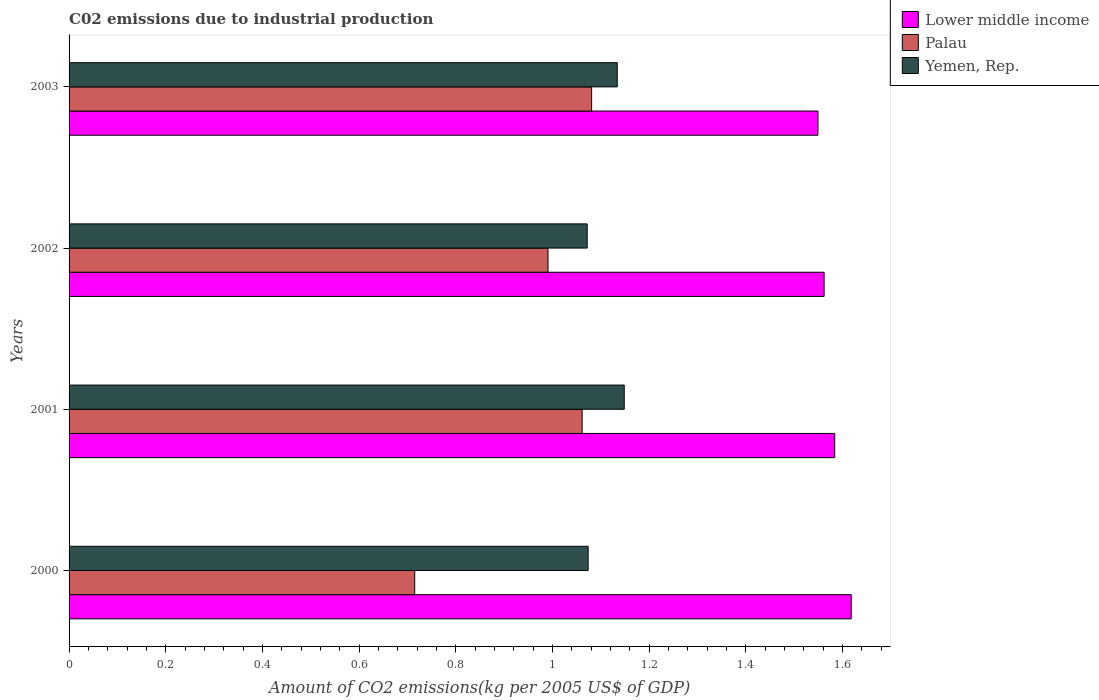How many different coloured bars are there?
Your answer should be very brief. 3. How many bars are there on the 3rd tick from the bottom?
Your response must be concise. 3. What is the amount of CO2 emitted due to industrial production in Lower middle income in 2002?
Your answer should be compact. 1.56. Across all years, what is the maximum amount of CO2 emitted due to industrial production in Yemen, Rep.?
Your answer should be compact. 1.15. Across all years, what is the minimum amount of CO2 emitted due to industrial production in Lower middle income?
Your response must be concise. 1.55. In which year was the amount of CO2 emitted due to industrial production in Palau maximum?
Offer a terse response. 2003. What is the total amount of CO2 emitted due to industrial production in Yemen, Rep. in the graph?
Provide a succinct answer. 4.43. What is the difference between the amount of CO2 emitted due to industrial production in Lower middle income in 2001 and that in 2003?
Provide a short and direct response. 0.03. What is the difference between the amount of CO2 emitted due to industrial production in Lower middle income in 2000 and the amount of CO2 emitted due to industrial production in Palau in 2001?
Your answer should be very brief. 0.56. What is the average amount of CO2 emitted due to industrial production in Lower middle income per year?
Offer a terse response. 1.58. In the year 2003, what is the difference between the amount of CO2 emitted due to industrial production in Palau and amount of CO2 emitted due to industrial production in Yemen, Rep.?
Your response must be concise. -0.05. In how many years, is the amount of CO2 emitted due to industrial production in Palau greater than 0.32 kg?
Give a very brief answer. 4. What is the ratio of the amount of CO2 emitted due to industrial production in Palau in 2000 to that in 2003?
Your answer should be very brief. 0.66. Is the amount of CO2 emitted due to industrial production in Yemen, Rep. in 2001 less than that in 2003?
Give a very brief answer. No. What is the difference between the highest and the second highest amount of CO2 emitted due to industrial production in Yemen, Rep.?
Your answer should be compact. 0.01. What is the difference between the highest and the lowest amount of CO2 emitted due to industrial production in Yemen, Rep.?
Provide a short and direct response. 0.08. Is the sum of the amount of CO2 emitted due to industrial production in Yemen, Rep. in 2001 and 2002 greater than the maximum amount of CO2 emitted due to industrial production in Lower middle income across all years?
Your answer should be very brief. Yes. What does the 1st bar from the top in 2002 represents?
Offer a very short reply. Yemen, Rep. What does the 3rd bar from the bottom in 2003 represents?
Provide a short and direct response. Yemen, Rep. How many legend labels are there?
Offer a very short reply. 3. How are the legend labels stacked?
Your answer should be very brief. Vertical. What is the title of the graph?
Your answer should be very brief. C02 emissions due to industrial production. What is the label or title of the X-axis?
Give a very brief answer. Amount of CO2 emissions(kg per 2005 US$ of GDP). What is the Amount of CO2 emissions(kg per 2005 US$ of GDP) of Lower middle income in 2000?
Give a very brief answer. 1.62. What is the Amount of CO2 emissions(kg per 2005 US$ of GDP) in Palau in 2000?
Make the answer very short. 0.71. What is the Amount of CO2 emissions(kg per 2005 US$ of GDP) in Yemen, Rep. in 2000?
Offer a very short reply. 1.07. What is the Amount of CO2 emissions(kg per 2005 US$ of GDP) of Lower middle income in 2001?
Give a very brief answer. 1.58. What is the Amount of CO2 emissions(kg per 2005 US$ of GDP) of Palau in 2001?
Your response must be concise. 1.06. What is the Amount of CO2 emissions(kg per 2005 US$ of GDP) in Yemen, Rep. in 2001?
Your response must be concise. 1.15. What is the Amount of CO2 emissions(kg per 2005 US$ of GDP) of Lower middle income in 2002?
Make the answer very short. 1.56. What is the Amount of CO2 emissions(kg per 2005 US$ of GDP) in Palau in 2002?
Your answer should be compact. 0.99. What is the Amount of CO2 emissions(kg per 2005 US$ of GDP) of Yemen, Rep. in 2002?
Offer a very short reply. 1.07. What is the Amount of CO2 emissions(kg per 2005 US$ of GDP) of Lower middle income in 2003?
Give a very brief answer. 1.55. What is the Amount of CO2 emissions(kg per 2005 US$ of GDP) of Palau in 2003?
Ensure brevity in your answer.  1.08. What is the Amount of CO2 emissions(kg per 2005 US$ of GDP) in Yemen, Rep. in 2003?
Make the answer very short. 1.13. Across all years, what is the maximum Amount of CO2 emissions(kg per 2005 US$ of GDP) of Lower middle income?
Provide a succinct answer. 1.62. Across all years, what is the maximum Amount of CO2 emissions(kg per 2005 US$ of GDP) of Palau?
Your answer should be compact. 1.08. Across all years, what is the maximum Amount of CO2 emissions(kg per 2005 US$ of GDP) in Yemen, Rep.?
Your response must be concise. 1.15. Across all years, what is the minimum Amount of CO2 emissions(kg per 2005 US$ of GDP) of Lower middle income?
Keep it short and to the point. 1.55. Across all years, what is the minimum Amount of CO2 emissions(kg per 2005 US$ of GDP) in Palau?
Offer a terse response. 0.71. Across all years, what is the minimum Amount of CO2 emissions(kg per 2005 US$ of GDP) of Yemen, Rep.?
Your answer should be very brief. 1.07. What is the total Amount of CO2 emissions(kg per 2005 US$ of GDP) of Lower middle income in the graph?
Keep it short and to the point. 6.31. What is the total Amount of CO2 emissions(kg per 2005 US$ of GDP) in Palau in the graph?
Offer a terse response. 3.85. What is the total Amount of CO2 emissions(kg per 2005 US$ of GDP) of Yemen, Rep. in the graph?
Ensure brevity in your answer.  4.43. What is the difference between the Amount of CO2 emissions(kg per 2005 US$ of GDP) in Lower middle income in 2000 and that in 2001?
Offer a terse response. 0.03. What is the difference between the Amount of CO2 emissions(kg per 2005 US$ of GDP) of Palau in 2000 and that in 2001?
Provide a short and direct response. -0.35. What is the difference between the Amount of CO2 emissions(kg per 2005 US$ of GDP) in Yemen, Rep. in 2000 and that in 2001?
Make the answer very short. -0.07. What is the difference between the Amount of CO2 emissions(kg per 2005 US$ of GDP) of Lower middle income in 2000 and that in 2002?
Give a very brief answer. 0.06. What is the difference between the Amount of CO2 emissions(kg per 2005 US$ of GDP) of Palau in 2000 and that in 2002?
Provide a succinct answer. -0.28. What is the difference between the Amount of CO2 emissions(kg per 2005 US$ of GDP) in Yemen, Rep. in 2000 and that in 2002?
Make the answer very short. 0. What is the difference between the Amount of CO2 emissions(kg per 2005 US$ of GDP) in Lower middle income in 2000 and that in 2003?
Your response must be concise. 0.07. What is the difference between the Amount of CO2 emissions(kg per 2005 US$ of GDP) in Palau in 2000 and that in 2003?
Your answer should be compact. -0.37. What is the difference between the Amount of CO2 emissions(kg per 2005 US$ of GDP) in Yemen, Rep. in 2000 and that in 2003?
Your answer should be very brief. -0.06. What is the difference between the Amount of CO2 emissions(kg per 2005 US$ of GDP) in Lower middle income in 2001 and that in 2002?
Provide a short and direct response. 0.02. What is the difference between the Amount of CO2 emissions(kg per 2005 US$ of GDP) in Palau in 2001 and that in 2002?
Provide a short and direct response. 0.07. What is the difference between the Amount of CO2 emissions(kg per 2005 US$ of GDP) in Yemen, Rep. in 2001 and that in 2002?
Your response must be concise. 0.08. What is the difference between the Amount of CO2 emissions(kg per 2005 US$ of GDP) in Lower middle income in 2001 and that in 2003?
Provide a succinct answer. 0.03. What is the difference between the Amount of CO2 emissions(kg per 2005 US$ of GDP) of Palau in 2001 and that in 2003?
Ensure brevity in your answer.  -0.02. What is the difference between the Amount of CO2 emissions(kg per 2005 US$ of GDP) in Yemen, Rep. in 2001 and that in 2003?
Make the answer very short. 0.01. What is the difference between the Amount of CO2 emissions(kg per 2005 US$ of GDP) in Lower middle income in 2002 and that in 2003?
Make the answer very short. 0.01. What is the difference between the Amount of CO2 emissions(kg per 2005 US$ of GDP) in Palau in 2002 and that in 2003?
Make the answer very short. -0.09. What is the difference between the Amount of CO2 emissions(kg per 2005 US$ of GDP) of Yemen, Rep. in 2002 and that in 2003?
Your response must be concise. -0.06. What is the difference between the Amount of CO2 emissions(kg per 2005 US$ of GDP) in Lower middle income in 2000 and the Amount of CO2 emissions(kg per 2005 US$ of GDP) in Palau in 2001?
Provide a short and direct response. 0.56. What is the difference between the Amount of CO2 emissions(kg per 2005 US$ of GDP) of Lower middle income in 2000 and the Amount of CO2 emissions(kg per 2005 US$ of GDP) of Yemen, Rep. in 2001?
Provide a succinct answer. 0.47. What is the difference between the Amount of CO2 emissions(kg per 2005 US$ of GDP) of Palau in 2000 and the Amount of CO2 emissions(kg per 2005 US$ of GDP) of Yemen, Rep. in 2001?
Your response must be concise. -0.43. What is the difference between the Amount of CO2 emissions(kg per 2005 US$ of GDP) of Lower middle income in 2000 and the Amount of CO2 emissions(kg per 2005 US$ of GDP) of Palau in 2002?
Make the answer very short. 0.63. What is the difference between the Amount of CO2 emissions(kg per 2005 US$ of GDP) of Lower middle income in 2000 and the Amount of CO2 emissions(kg per 2005 US$ of GDP) of Yemen, Rep. in 2002?
Your answer should be compact. 0.55. What is the difference between the Amount of CO2 emissions(kg per 2005 US$ of GDP) in Palau in 2000 and the Amount of CO2 emissions(kg per 2005 US$ of GDP) in Yemen, Rep. in 2002?
Ensure brevity in your answer.  -0.36. What is the difference between the Amount of CO2 emissions(kg per 2005 US$ of GDP) of Lower middle income in 2000 and the Amount of CO2 emissions(kg per 2005 US$ of GDP) of Palau in 2003?
Make the answer very short. 0.54. What is the difference between the Amount of CO2 emissions(kg per 2005 US$ of GDP) of Lower middle income in 2000 and the Amount of CO2 emissions(kg per 2005 US$ of GDP) of Yemen, Rep. in 2003?
Make the answer very short. 0.48. What is the difference between the Amount of CO2 emissions(kg per 2005 US$ of GDP) of Palau in 2000 and the Amount of CO2 emissions(kg per 2005 US$ of GDP) of Yemen, Rep. in 2003?
Ensure brevity in your answer.  -0.42. What is the difference between the Amount of CO2 emissions(kg per 2005 US$ of GDP) in Lower middle income in 2001 and the Amount of CO2 emissions(kg per 2005 US$ of GDP) in Palau in 2002?
Your answer should be compact. 0.59. What is the difference between the Amount of CO2 emissions(kg per 2005 US$ of GDP) of Lower middle income in 2001 and the Amount of CO2 emissions(kg per 2005 US$ of GDP) of Yemen, Rep. in 2002?
Offer a very short reply. 0.51. What is the difference between the Amount of CO2 emissions(kg per 2005 US$ of GDP) of Palau in 2001 and the Amount of CO2 emissions(kg per 2005 US$ of GDP) of Yemen, Rep. in 2002?
Keep it short and to the point. -0.01. What is the difference between the Amount of CO2 emissions(kg per 2005 US$ of GDP) of Lower middle income in 2001 and the Amount of CO2 emissions(kg per 2005 US$ of GDP) of Palau in 2003?
Give a very brief answer. 0.5. What is the difference between the Amount of CO2 emissions(kg per 2005 US$ of GDP) in Lower middle income in 2001 and the Amount of CO2 emissions(kg per 2005 US$ of GDP) in Yemen, Rep. in 2003?
Ensure brevity in your answer.  0.45. What is the difference between the Amount of CO2 emissions(kg per 2005 US$ of GDP) in Palau in 2001 and the Amount of CO2 emissions(kg per 2005 US$ of GDP) in Yemen, Rep. in 2003?
Provide a short and direct response. -0.07. What is the difference between the Amount of CO2 emissions(kg per 2005 US$ of GDP) in Lower middle income in 2002 and the Amount of CO2 emissions(kg per 2005 US$ of GDP) in Palau in 2003?
Provide a short and direct response. 0.48. What is the difference between the Amount of CO2 emissions(kg per 2005 US$ of GDP) of Lower middle income in 2002 and the Amount of CO2 emissions(kg per 2005 US$ of GDP) of Yemen, Rep. in 2003?
Ensure brevity in your answer.  0.43. What is the difference between the Amount of CO2 emissions(kg per 2005 US$ of GDP) in Palau in 2002 and the Amount of CO2 emissions(kg per 2005 US$ of GDP) in Yemen, Rep. in 2003?
Give a very brief answer. -0.14. What is the average Amount of CO2 emissions(kg per 2005 US$ of GDP) of Lower middle income per year?
Your answer should be very brief. 1.58. What is the average Amount of CO2 emissions(kg per 2005 US$ of GDP) of Yemen, Rep. per year?
Provide a short and direct response. 1.11. In the year 2000, what is the difference between the Amount of CO2 emissions(kg per 2005 US$ of GDP) of Lower middle income and Amount of CO2 emissions(kg per 2005 US$ of GDP) of Palau?
Offer a very short reply. 0.9. In the year 2000, what is the difference between the Amount of CO2 emissions(kg per 2005 US$ of GDP) in Lower middle income and Amount of CO2 emissions(kg per 2005 US$ of GDP) in Yemen, Rep.?
Make the answer very short. 0.54. In the year 2000, what is the difference between the Amount of CO2 emissions(kg per 2005 US$ of GDP) of Palau and Amount of CO2 emissions(kg per 2005 US$ of GDP) of Yemen, Rep.?
Offer a terse response. -0.36. In the year 2001, what is the difference between the Amount of CO2 emissions(kg per 2005 US$ of GDP) of Lower middle income and Amount of CO2 emissions(kg per 2005 US$ of GDP) of Palau?
Offer a terse response. 0.52. In the year 2001, what is the difference between the Amount of CO2 emissions(kg per 2005 US$ of GDP) of Lower middle income and Amount of CO2 emissions(kg per 2005 US$ of GDP) of Yemen, Rep.?
Ensure brevity in your answer.  0.44. In the year 2001, what is the difference between the Amount of CO2 emissions(kg per 2005 US$ of GDP) in Palau and Amount of CO2 emissions(kg per 2005 US$ of GDP) in Yemen, Rep.?
Ensure brevity in your answer.  -0.09. In the year 2002, what is the difference between the Amount of CO2 emissions(kg per 2005 US$ of GDP) in Lower middle income and Amount of CO2 emissions(kg per 2005 US$ of GDP) in Palau?
Keep it short and to the point. 0.57. In the year 2002, what is the difference between the Amount of CO2 emissions(kg per 2005 US$ of GDP) in Lower middle income and Amount of CO2 emissions(kg per 2005 US$ of GDP) in Yemen, Rep.?
Provide a succinct answer. 0.49. In the year 2002, what is the difference between the Amount of CO2 emissions(kg per 2005 US$ of GDP) in Palau and Amount of CO2 emissions(kg per 2005 US$ of GDP) in Yemen, Rep.?
Offer a very short reply. -0.08. In the year 2003, what is the difference between the Amount of CO2 emissions(kg per 2005 US$ of GDP) in Lower middle income and Amount of CO2 emissions(kg per 2005 US$ of GDP) in Palau?
Your answer should be very brief. 0.47. In the year 2003, what is the difference between the Amount of CO2 emissions(kg per 2005 US$ of GDP) in Lower middle income and Amount of CO2 emissions(kg per 2005 US$ of GDP) in Yemen, Rep.?
Your answer should be compact. 0.42. In the year 2003, what is the difference between the Amount of CO2 emissions(kg per 2005 US$ of GDP) of Palau and Amount of CO2 emissions(kg per 2005 US$ of GDP) of Yemen, Rep.?
Make the answer very short. -0.05. What is the ratio of the Amount of CO2 emissions(kg per 2005 US$ of GDP) of Lower middle income in 2000 to that in 2001?
Offer a very short reply. 1.02. What is the ratio of the Amount of CO2 emissions(kg per 2005 US$ of GDP) in Palau in 2000 to that in 2001?
Keep it short and to the point. 0.67. What is the ratio of the Amount of CO2 emissions(kg per 2005 US$ of GDP) in Yemen, Rep. in 2000 to that in 2001?
Your answer should be very brief. 0.94. What is the ratio of the Amount of CO2 emissions(kg per 2005 US$ of GDP) in Lower middle income in 2000 to that in 2002?
Provide a short and direct response. 1.04. What is the ratio of the Amount of CO2 emissions(kg per 2005 US$ of GDP) of Palau in 2000 to that in 2002?
Your answer should be very brief. 0.72. What is the ratio of the Amount of CO2 emissions(kg per 2005 US$ of GDP) of Yemen, Rep. in 2000 to that in 2002?
Ensure brevity in your answer.  1. What is the ratio of the Amount of CO2 emissions(kg per 2005 US$ of GDP) in Lower middle income in 2000 to that in 2003?
Provide a succinct answer. 1.04. What is the ratio of the Amount of CO2 emissions(kg per 2005 US$ of GDP) of Palau in 2000 to that in 2003?
Keep it short and to the point. 0.66. What is the ratio of the Amount of CO2 emissions(kg per 2005 US$ of GDP) of Yemen, Rep. in 2000 to that in 2003?
Provide a short and direct response. 0.95. What is the ratio of the Amount of CO2 emissions(kg per 2005 US$ of GDP) in Lower middle income in 2001 to that in 2002?
Provide a succinct answer. 1.01. What is the ratio of the Amount of CO2 emissions(kg per 2005 US$ of GDP) in Palau in 2001 to that in 2002?
Provide a succinct answer. 1.07. What is the ratio of the Amount of CO2 emissions(kg per 2005 US$ of GDP) in Yemen, Rep. in 2001 to that in 2002?
Make the answer very short. 1.07. What is the ratio of the Amount of CO2 emissions(kg per 2005 US$ of GDP) in Lower middle income in 2001 to that in 2003?
Provide a succinct answer. 1.02. What is the ratio of the Amount of CO2 emissions(kg per 2005 US$ of GDP) in Palau in 2001 to that in 2003?
Your answer should be compact. 0.98. What is the ratio of the Amount of CO2 emissions(kg per 2005 US$ of GDP) of Yemen, Rep. in 2001 to that in 2003?
Offer a very short reply. 1.01. What is the ratio of the Amount of CO2 emissions(kg per 2005 US$ of GDP) in Lower middle income in 2002 to that in 2003?
Offer a terse response. 1.01. What is the ratio of the Amount of CO2 emissions(kg per 2005 US$ of GDP) in Palau in 2002 to that in 2003?
Provide a short and direct response. 0.92. What is the ratio of the Amount of CO2 emissions(kg per 2005 US$ of GDP) of Yemen, Rep. in 2002 to that in 2003?
Give a very brief answer. 0.95. What is the difference between the highest and the second highest Amount of CO2 emissions(kg per 2005 US$ of GDP) in Lower middle income?
Offer a terse response. 0.03. What is the difference between the highest and the second highest Amount of CO2 emissions(kg per 2005 US$ of GDP) of Palau?
Offer a terse response. 0.02. What is the difference between the highest and the second highest Amount of CO2 emissions(kg per 2005 US$ of GDP) of Yemen, Rep.?
Your answer should be very brief. 0.01. What is the difference between the highest and the lowest Amount of CO2 emissions(kg per 2005 US$ of GDP) of Lower middle income?
Offer a very short reply. 0.07. What is the difference between the highest and the lowest Amount of CO2 emissions(kg per 2005 US$ of GDP) in Palau?
Offer a very short reply. 0.37. What is the difference between the highest and the lowest Amount of CO2 emissions(kg per 2005 US$ of GDP) of Yemen, Rep.?
Provide a succinct answer. 0.08. 